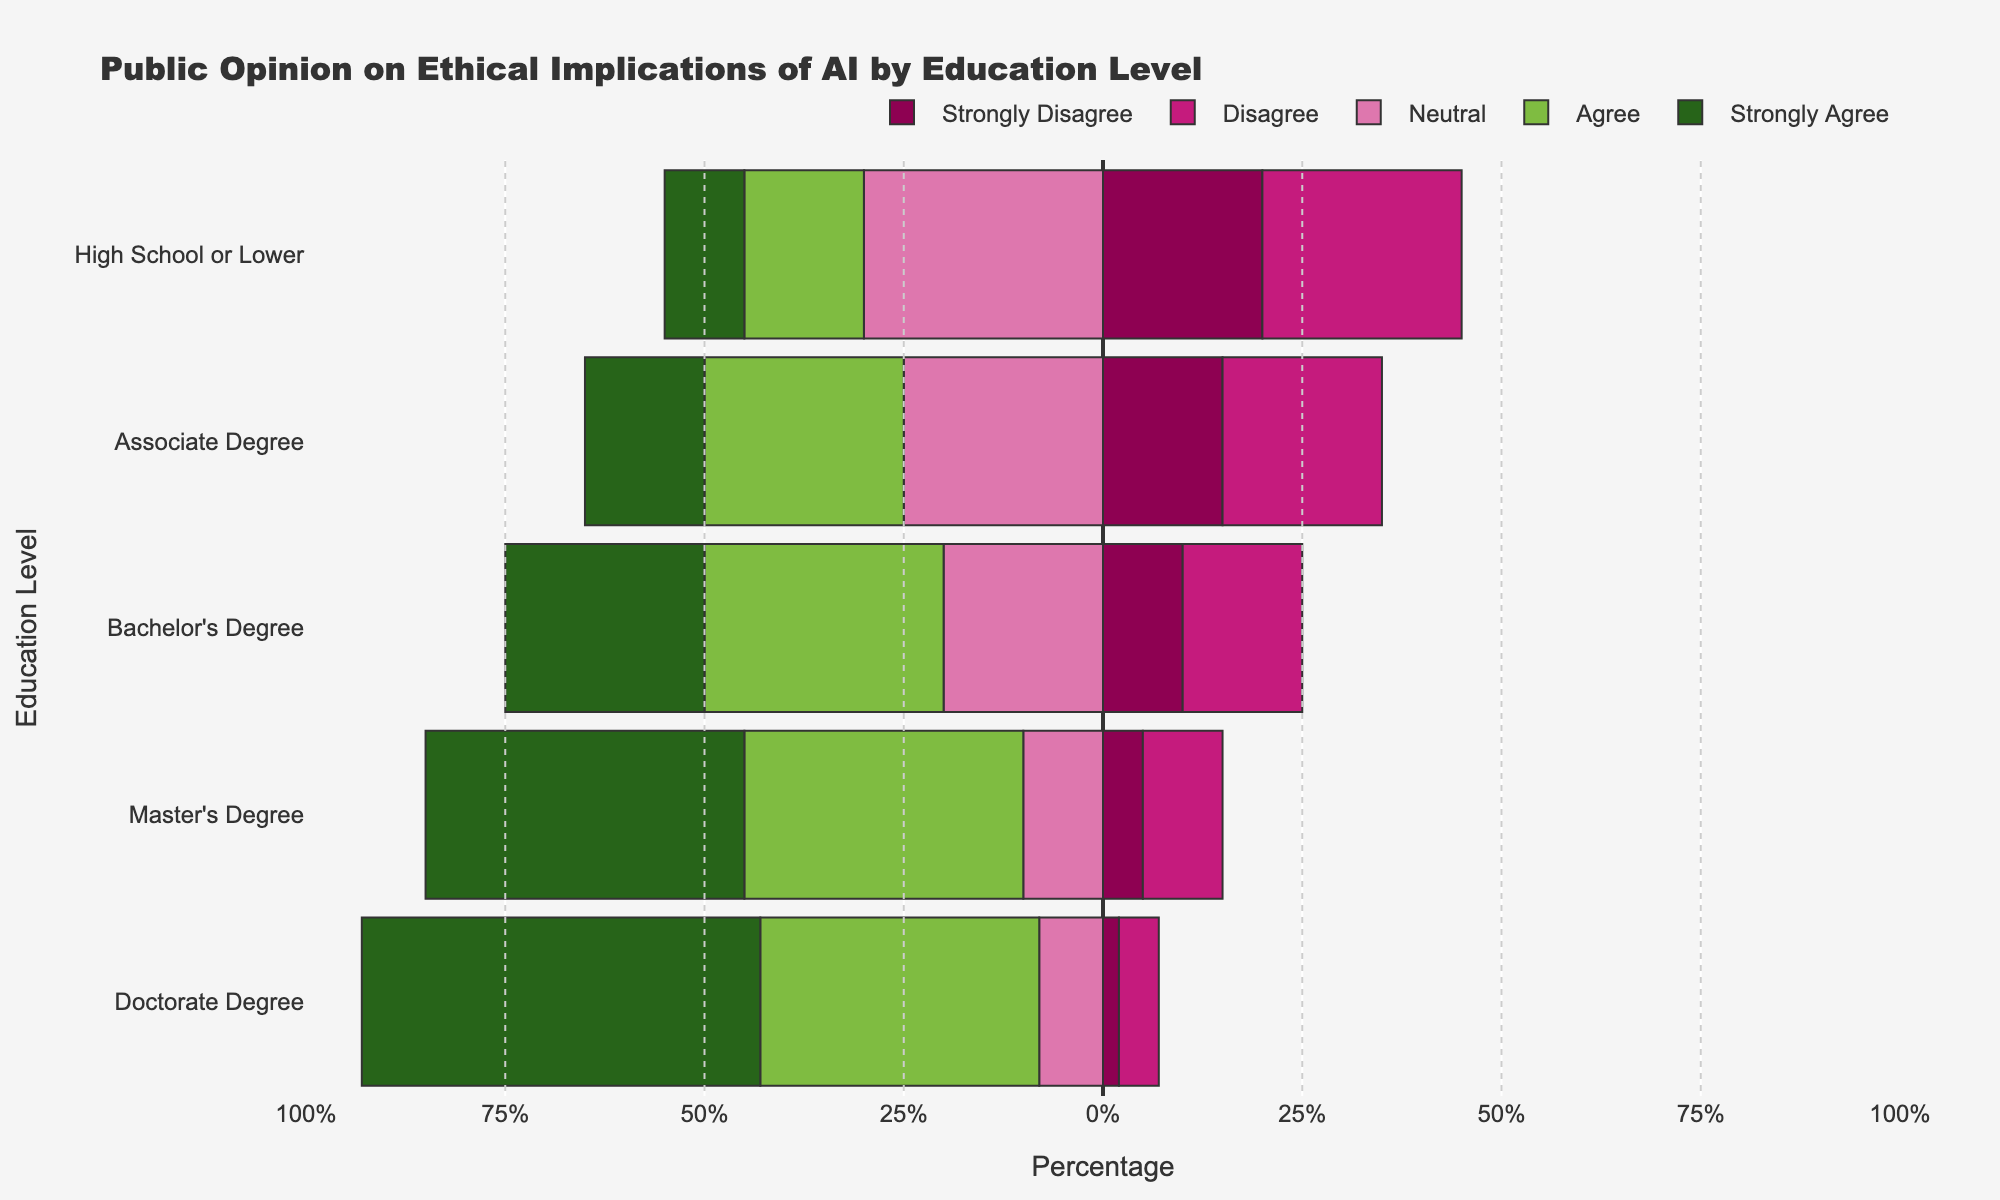Which education level has the highest percentage of respondents who strongly agree that AI has ethical implications? To find this, look at the "Strongly Agree" segment across all education levels. The bar for "Doctorate Degree" extends the farthest to the left, indicating it has the highest percentage.
Answer: Doctorate Degree Which education level has the highest combined percentage of respondents who agree and strongly agree that AI has ethical implications? Sum up the percentages of "Agree" and "Strongly Agree" for each education level and compare. "Doctorate Degree" has "Agree" (35%) and "Strongly Agree" (50%), summed up to 85%.
Answer: Doctorate Degree What is the difference in the percentage of neutral responses between High School or Lower and Master's Degree? Identify the "Neutral" segment for both levels. High School or Lower has 30% neutral, and Master's Degree has 10% neutral. Subtract to find the difference: 30% - 10%.
Answer: 20% Which education level shows the least disagreement (both "Disagree" and "Strongly Disagree") towards AI's ethical implications? Sum the percentages of "Disagree" and "Strongly Disagree" for each level. "Doctorate Degree" shows the smallest total with 5% (Disagree) + 2% (Strongly Disagree) = 7%.
Answer: Doctorate Degree How does the percentage of agreement ("Agree" + "Strongly Agree") for Bachelor's Degree compare with that for Associate Degree? Sum the percentages for "Agree" and "Strongly Agree" for both levels. Bachelor's Degree has 30% + 25% = 55%, and Associate Degree has 25% + 15% = 40%. Bachelor's Degree (55%) is higher.
Answer: Higher What is the median percentage of neutral responses across all education levels? Identify the neutral percentages: 30%, 25%, 20%, 10%, and 8%. Arrange in order: 8%, 10%, 20%, 25%, 30%. The middle value (median) is 20%.
Answer: 20% Which education level has the highest total percentage of agreement (consider both "Agree" and "Strongly Agree")? To determine the highest total, sum the "Agree" and "Strongly Agree" percentages for each education level, and compare them. Doctorate Degree has 35% + 50% = 85%, which is the highest.
Answer: Doctorate Degree What is the total percentage of disagreement (sum of "Disagree" and "Strongly Disagree") for Associate Degree and Bachelor's Degree combined? Sum "Disagree" and "Strongly Disagree" for both levels, then add those together. Associate Degree: 20% + 15% = 35%. Bachelor's Degree: 15% + 10% = 25%. Combined: 35% + 25% = 60%.
Answer: 60% 